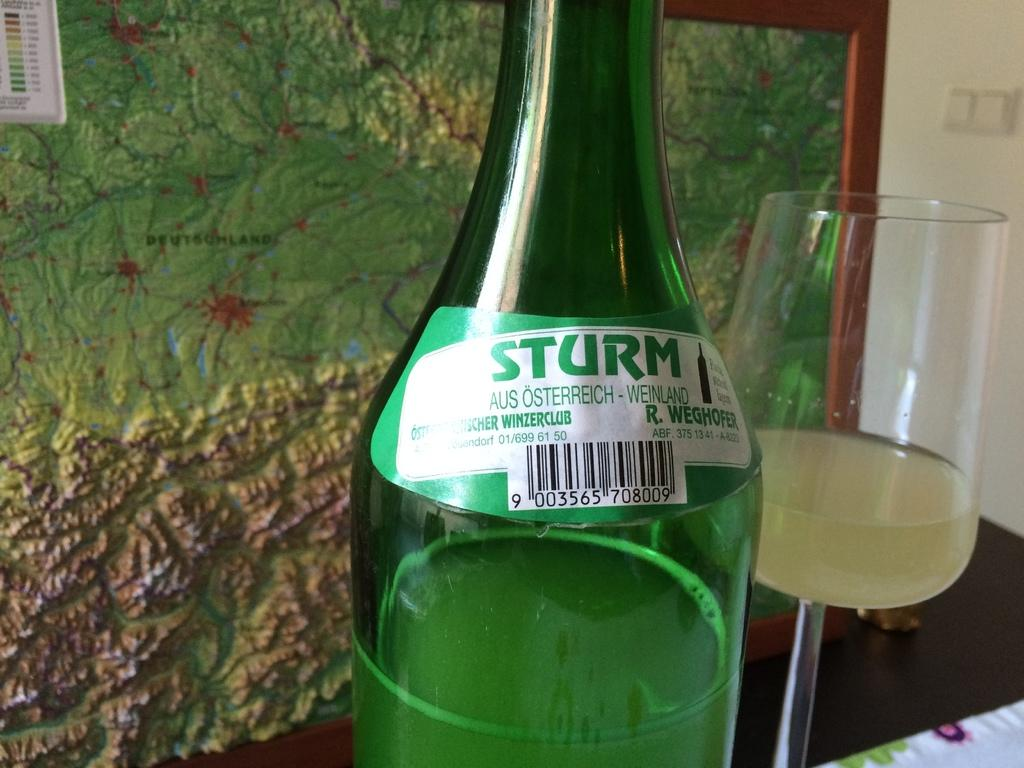<image>
Relay a brief, clear account of the picture shown. Green Sturm bottle next to an almost empty wine glass. 